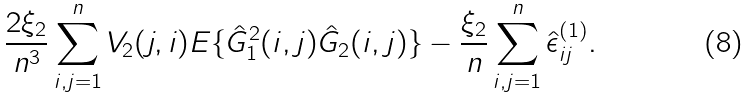<formula> <loc_0><loc_0><loc_500><loc_500>\frac { 2 \xi _ { 2 } } { n ^ { 3 } } \sum _ { i , j = 1 } ^ { n } V _ { 2 } ( j , i ) { E } \{ \hat { G } ^ { 2 } _ { 1 } ( i , j ) \hat { G } _ { 2 } ( i , j ) \} - \frac { \xi _ { 2 } } { n } \sum _ { i , j = 1 } ^ { n } \hat { \epsilon } ^ { ( 1 ) } _ { i j } .</formula> 